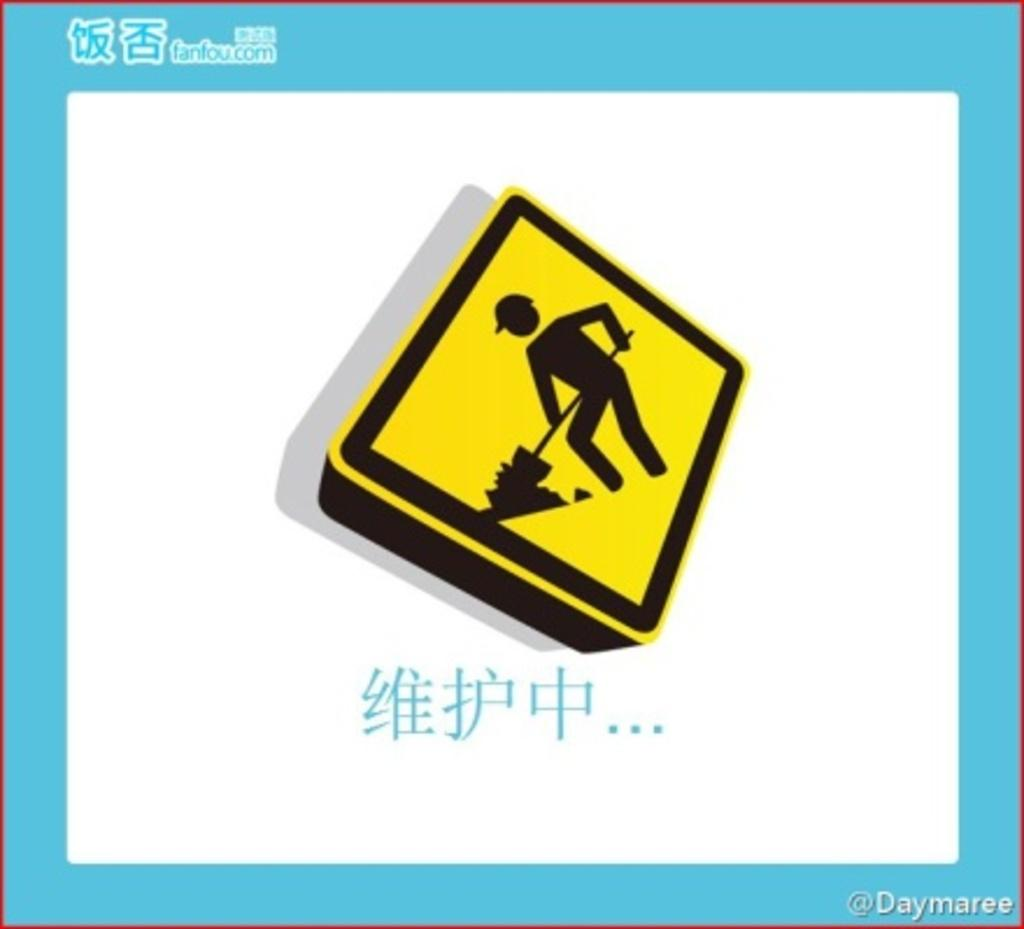Provide a one-sentence caption for the provided image. A painting of a construction sign is surround by blue matting that says fanfou.com on it. 